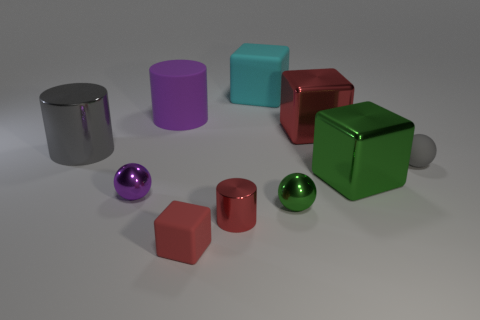Subtract all tiny matte spheres. How many spheres are left? 2 Subtract all brown spheres. How many red blocks are left? 2 Subtract all gray balls. How many balls are left? 2 Subtract 3 spheres. How many spheres are left? 0 Subtract 0 yellow cylinders. How many objects are left? 10 Subtract all balls. How many objects are left? 7 Subtract all purple cylinders. Subtract all gray blocks. How many cylinders are left? 2 Subtract all small red shiny things. Subtract all large gray cylinders. How many objects are left? 8 Add 3 tiny gray things. How many tiny gray things are left? 4 Add 6 large purple objects. How many large purple objects exist? 7 